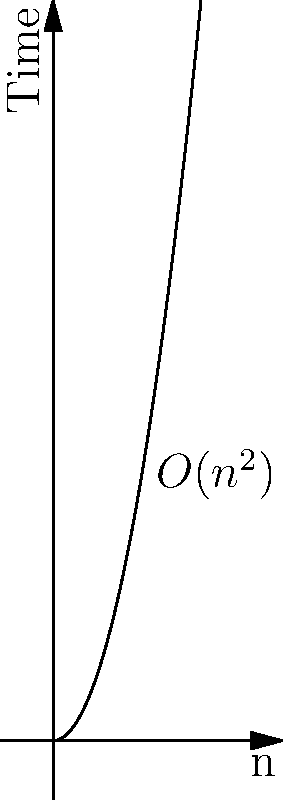As a PHP developer working on optimizing a Composer package, you encounter a nested loop algorithm. The time complexity graph of this algorithm is shown above. What is the Big O notation for the time complexity of this algorithm? To determine the Big O notation of the algorithm, let's analyze the graph:

1. The x-axis represents the input size (n), and the y-axis represents the time taken.

2. The curve shown in the graph is a quadratic function, as it's increasing at a rate faster than linear but slower than exponential.

3. The shape of the curve closely resembles $f(n) = n^2$, which is characteristic of algorithms with nested loops where the outer loop runs n times and the inner loop also runs n times.

4. This quadratic growth is typical of algorithms with two nested loops, each iterating over the input size.

5. The label on the graph also indicates $O(n^2)$, which confirms our analysis.

Therefore, the Big O notation for the time complexity of this algorithm is $O(n^2)$.
Answer: $O(n^2)$ 